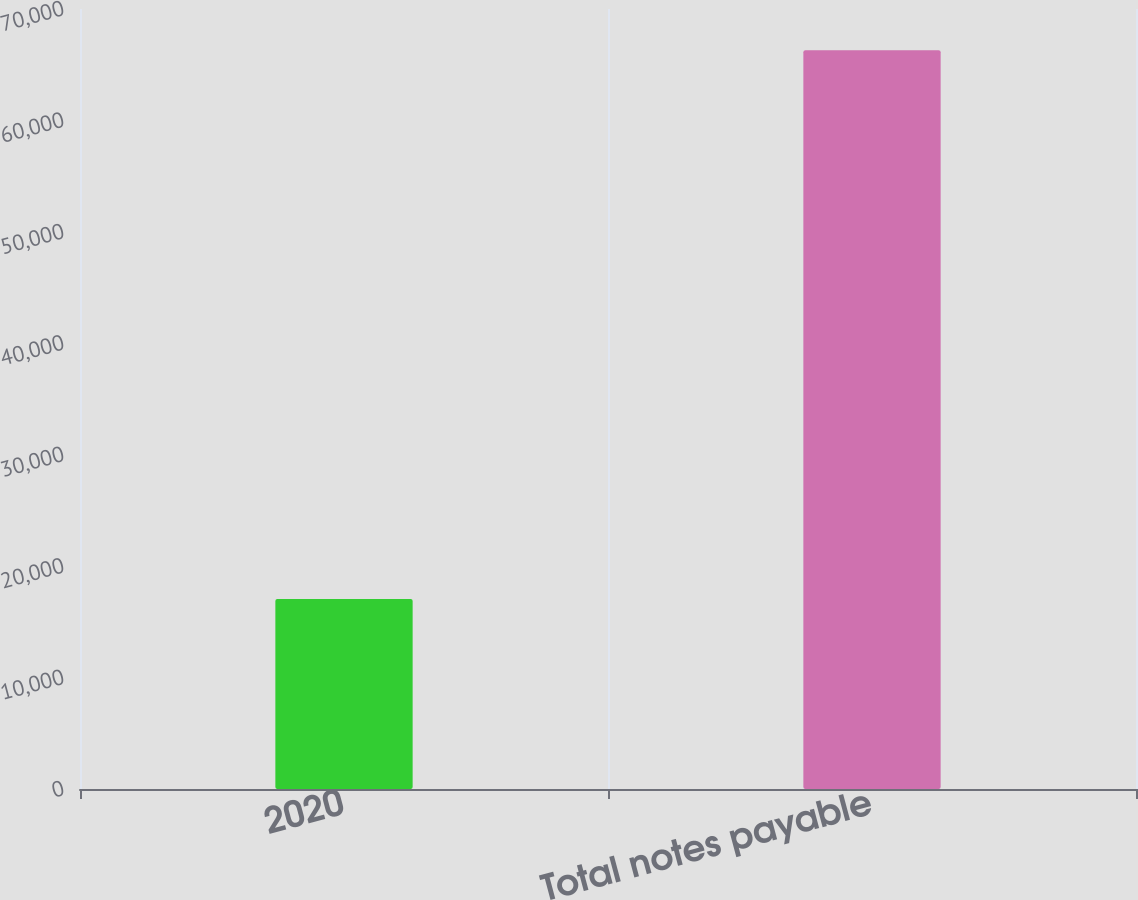<chart> <loc_0><loc_0><loc_500><loc_500><bar_chart><fcel>2020<fcel>Total notes payable<nl><fcel>17043<fcel>66306<nl></chart> 